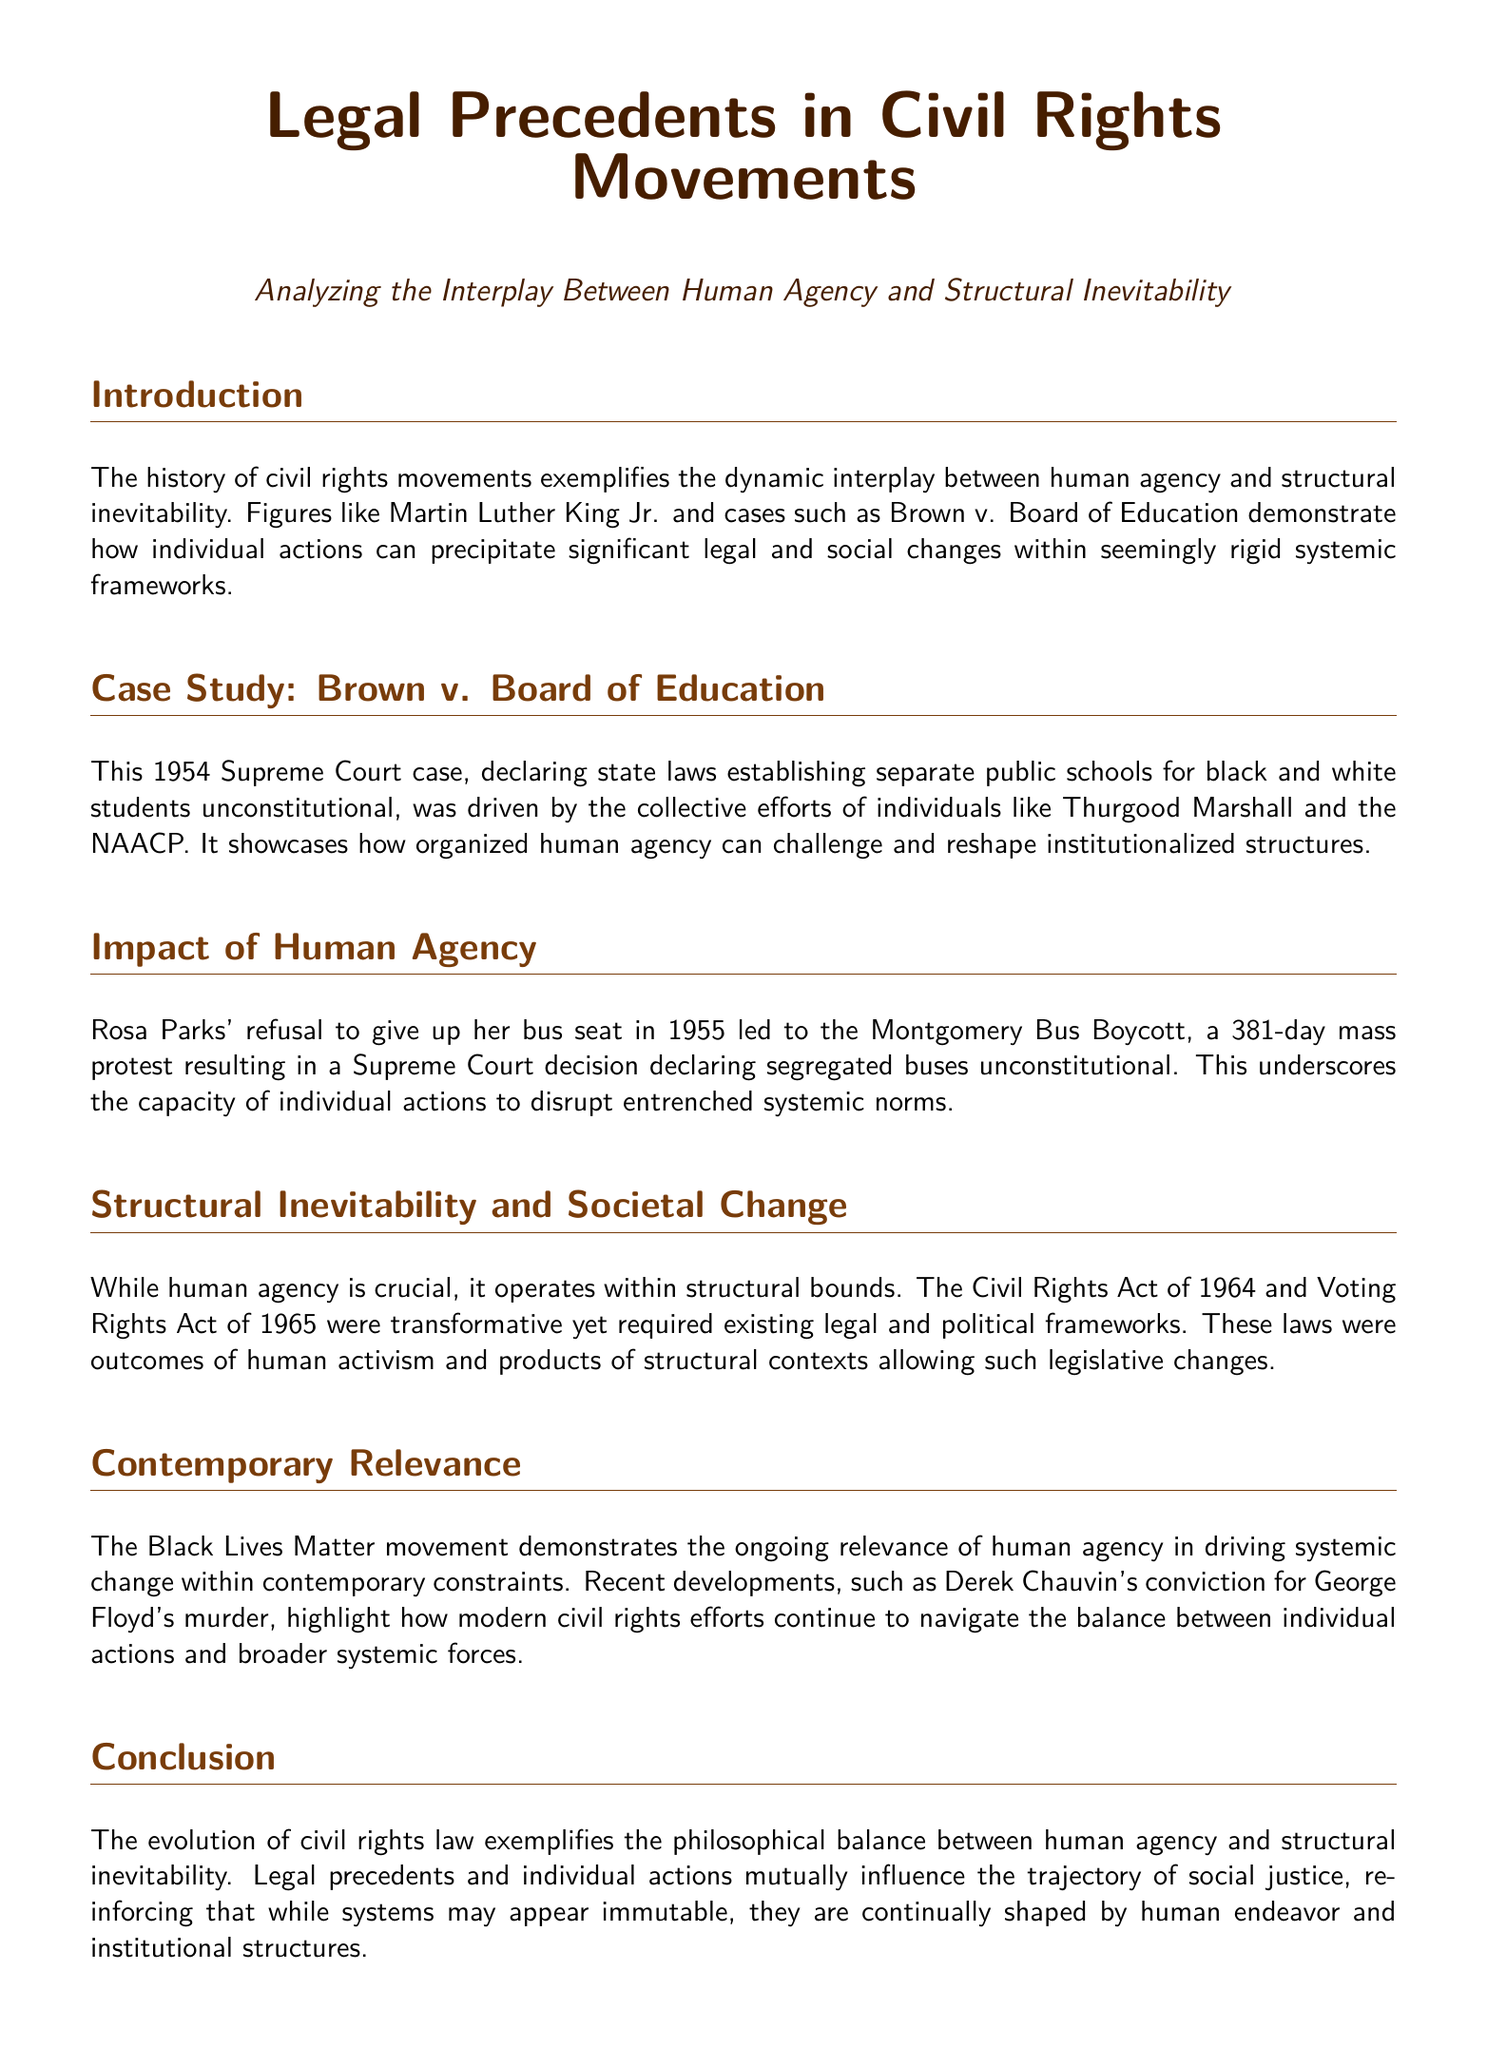What is the title of the document? The title of the document is stated at the beginning, highlighting the main focus on legal precedents in civil rights movements.
Answer: Legal Precedents in Civil Rights Movements Who wrote the brief case study mentioned? The case study highlights the contributions of Thurgood Marshall and the NAACP in the mentioned Supreme Court case.
Answer: Thurgood Marshall and the NAACP What year was Brown v. Board of Education decided? The document notes the year of the Supreme Court decision regarding separate public schools for black and white students as 1954.
Answer: 1954 What significant event did Rosa Parks' actions lead to? The document describes the outcome of Rosa Parks' refusal to give up her bus seat as leading to the Montgomery Bus Boycott.
Answer: Montgomery Bus Boycott What two major acts were passed in 1964 and 1965? These acts are referenced in the document concerning transformative legal changes resulting from human activism within structural contexts.
Answer: Civil Rights Act and Voting Rights Act Which movement is highlighted for its contemporary relevance? The document discusses a current movement that continues to advocate for systemic change in light of historical civil rights efforts.
Answer: Black Lives Matter What was a key legal ruling resulting from the Montgomery Bus Boycott? The document states that the boycott led to a Supreme Court decision declaring segregated buses unconstitutional.
Answer: Segregated buses unconstitutional What does the document conclude about the relationship between human agency and structural inevitability? The conclusion summarizes the document's argument about how both elements influence social justice evolution.
Answer: They mutually influence the trajectory of social justice 